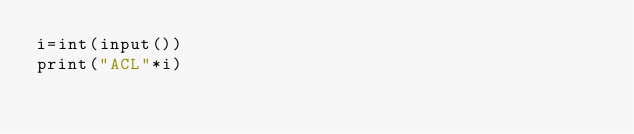<code> <loc_0><loc_0><loc_500><loc_500><_Python_>i=int(input())
print("ACL"*i)</code> 